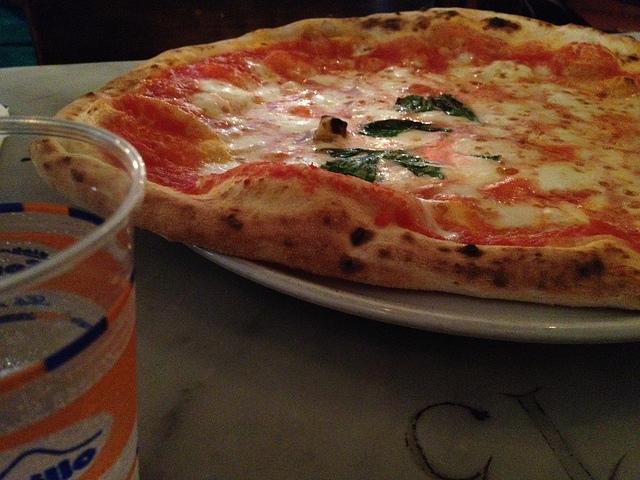What type of the food is in the picture?
Concise answer only. Pizza. Is this food ready to be eaten?
Concise answer only. Yes. What is on the pizza?
Quick response, please. Cheese. Is the pizza cut?
Give a very brief answer. No. What is the green stuff on the pizza?
Be succinct. Spinach. What is the main topping?
Give a very brief answer. Cheese. What food is being served?
Quick response, please. Pizza. Is this pizza cut up?
Concise answer only. No. What vegetable is on top of the pizza?
Give a very brief answer. Spinach. What are the green vegetables on the pizza?
Keep it brief. Spinach. Has this food been cut?
Give a very brief answer. No. Has this pizza already been cut into slices?
Give a very brief answer. No. What topping is on the pizza?
Answer briefly. Cheese. Is this a healthy or unhealthy meal for one?
Give a very brief answer. Unhealthy. 